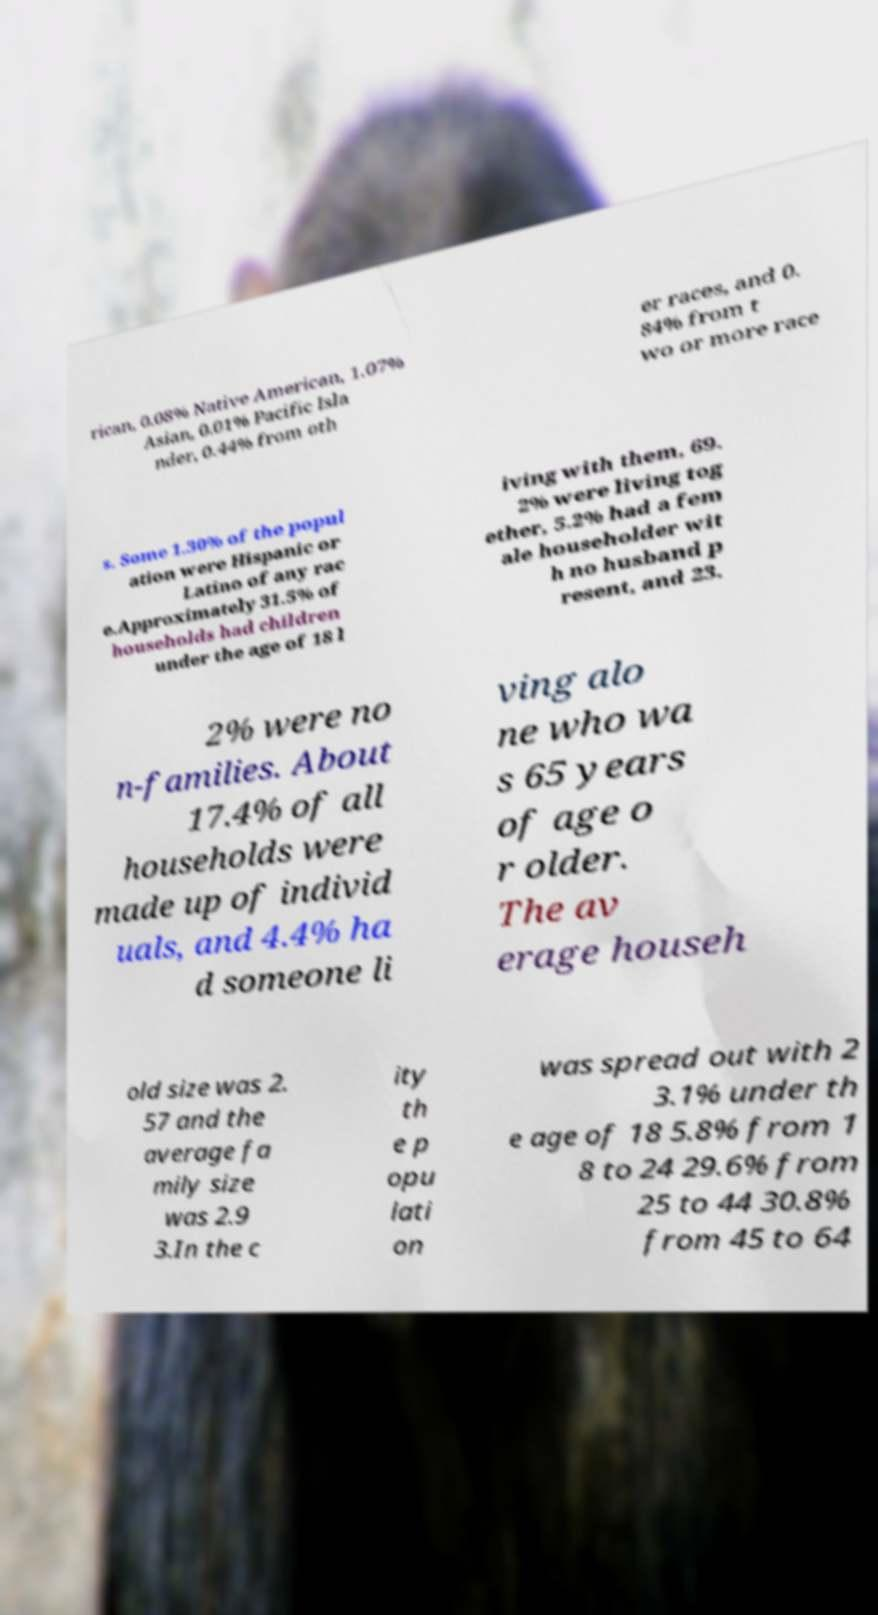I need the written content from this picture converted into text. Can you do that? rican, 0.08% Native American, 1.07% Asian, 0.01% Pacific Isla nder, 0.44% from oth er races, and 0. 84% from t wo or more race s. Some 1.30% of the popul ation were Hispanic or Latino of any rac e.Approximately 31.5% of households had children under the age of 18 l iving with them, 69. 2% were living tog ether, 5.2% had a fem ale householder wit h no husband p resent, and 23. 2% were no n-families. About 17.4% of all households were made up of individ uals, and 4.4% ha d someone li ving alo ne who wa s 65 years of age o r older. The av erage househ old size was 2. 57 and the average fa mily size was 2.9 3.In the c ity th e p opu lati on was spread out with 2 3.1% under th e age of 18 5.8% from 1 8 to 24 29.6% from 25 to 44 30.8% from 45 to 64 